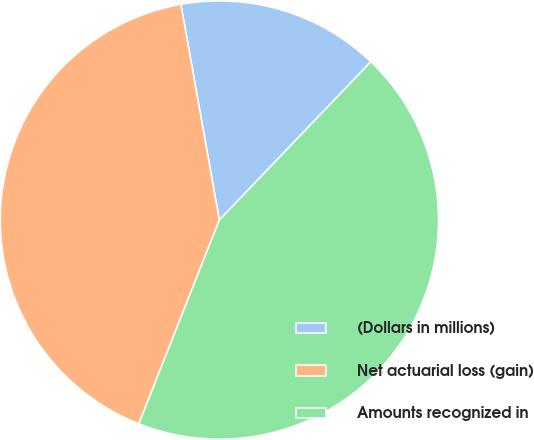<chart> <loc_0><loc_0><loc_500><loc_500><pie_chart><fcel>(Dollars in millions)<fcel>Net actuarial loss (gain)<fcel>Amounts recognized in<nl><fcel>14.96%<fcel>41.2%<fcel>43.84%<nl></chart> 